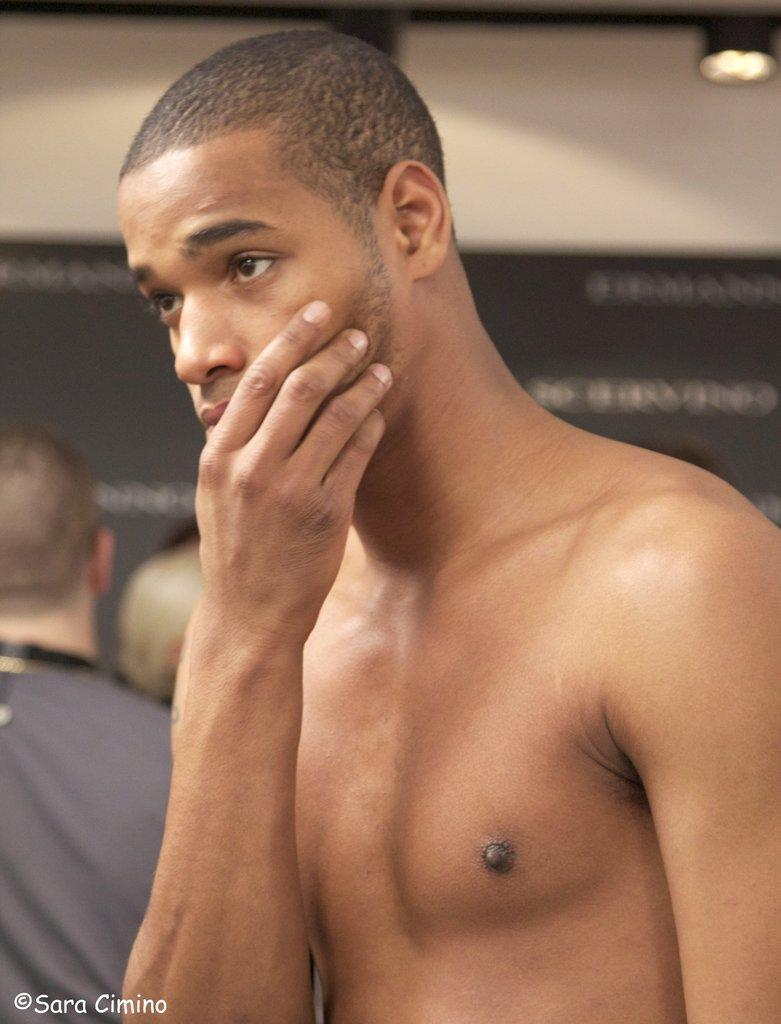Who is the main subject in the image? There is a person in the center of the image. Can you describe the surroundings of the main subject? There are persons standing in the background of the image. What type of sand can be seen on the person's shirt in the image? There is no sand or shirt visible in the image; the main subject is a person in the center, and there are persons standing in the background. 